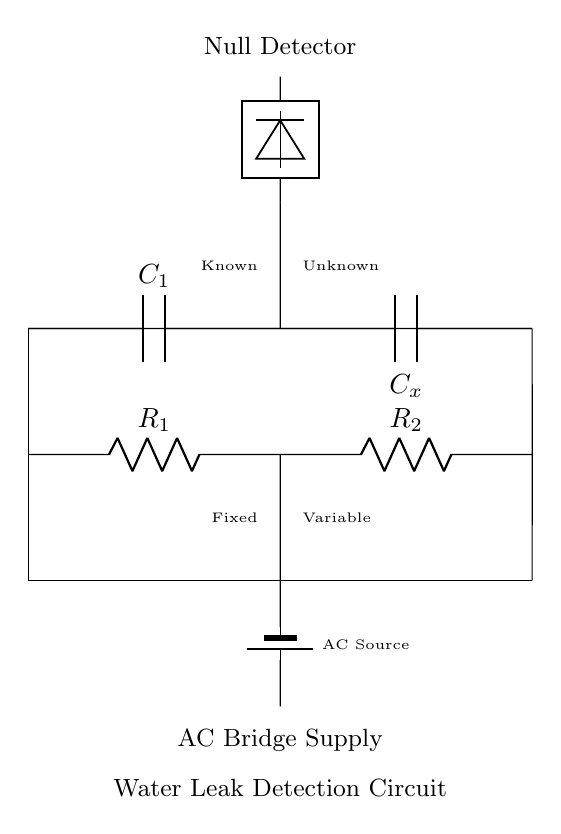What are the main components in this circuit? The main components in this circuit are two resistors, two capacitors, a battery, and a null detector. The resistors are named R1 and R2, and the capacitors are C1 and Cx.
Answer: Resistors and capacitors What is the purpose of the null detector? The null detector is used to identify any changes in the capacitance or resistance in the circuit, indicating the presence of a water leak. It will show a null reading when the bridge is balanced, alerting to a leak when it is not.
Answer: Detect water leaks What type of current does this circuit use? This circuit uses Alternating Current (AC) as indicated by the labeled AC source in the diagram, which powers the bridge circuit.
Answer: Alternating Current What is the relationship between the known and unknown components? The circuit compares known values (components R1 and C1) with the unknown values (R2 and Cx) to determine discrepancies that may indicate a leak. This comparison is essential for achieving a balanced bridge condition.
Answer: Comparison for leakage How does the capacitance bridge work for detecting leaks? The capacitance bridge works by measuring the difference in capacitance between the known capacitor (C1) and the unknown capacitor (Cx). If water enters the system, it changes the dielectric constant and capacitance value of Cx, which can be detected by the null detector as an imbalance in the circuit.
Answer: Measures capacitance difference What do R1 and R2 represent in relation to the plumbing system? R1 is fixed and represents a reference resistance, while R2 is variable and can represent a resistance change due to factors like corrosion or moisture in the plumbing system. This allows for monitoring and adjustments in the circuit based on real-time changes in the plumbing.
Answer: Reference and variable resistances What happens when there is a water leak concerning the capacitors in the circuit? A water leak increases the capacitance of Cx due to the water's dielectric properties compared to the air, leading to an imbalance which the null detector will register, indicating a leak.
Answer: Increases capacitance of Cx 